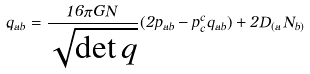Convert formula to latex. <formula><loc_0><loc_0><loc_500><loc_500>\dot { q } _ { a b } = \frac { 1 6 \pi G N } { \sqrt { \det q } } ( 2 p _ { a b } - p ^ { c } _ { c } q _ { a b } ) + 2 D _ { ( a } N _ { b ) }</formula> 